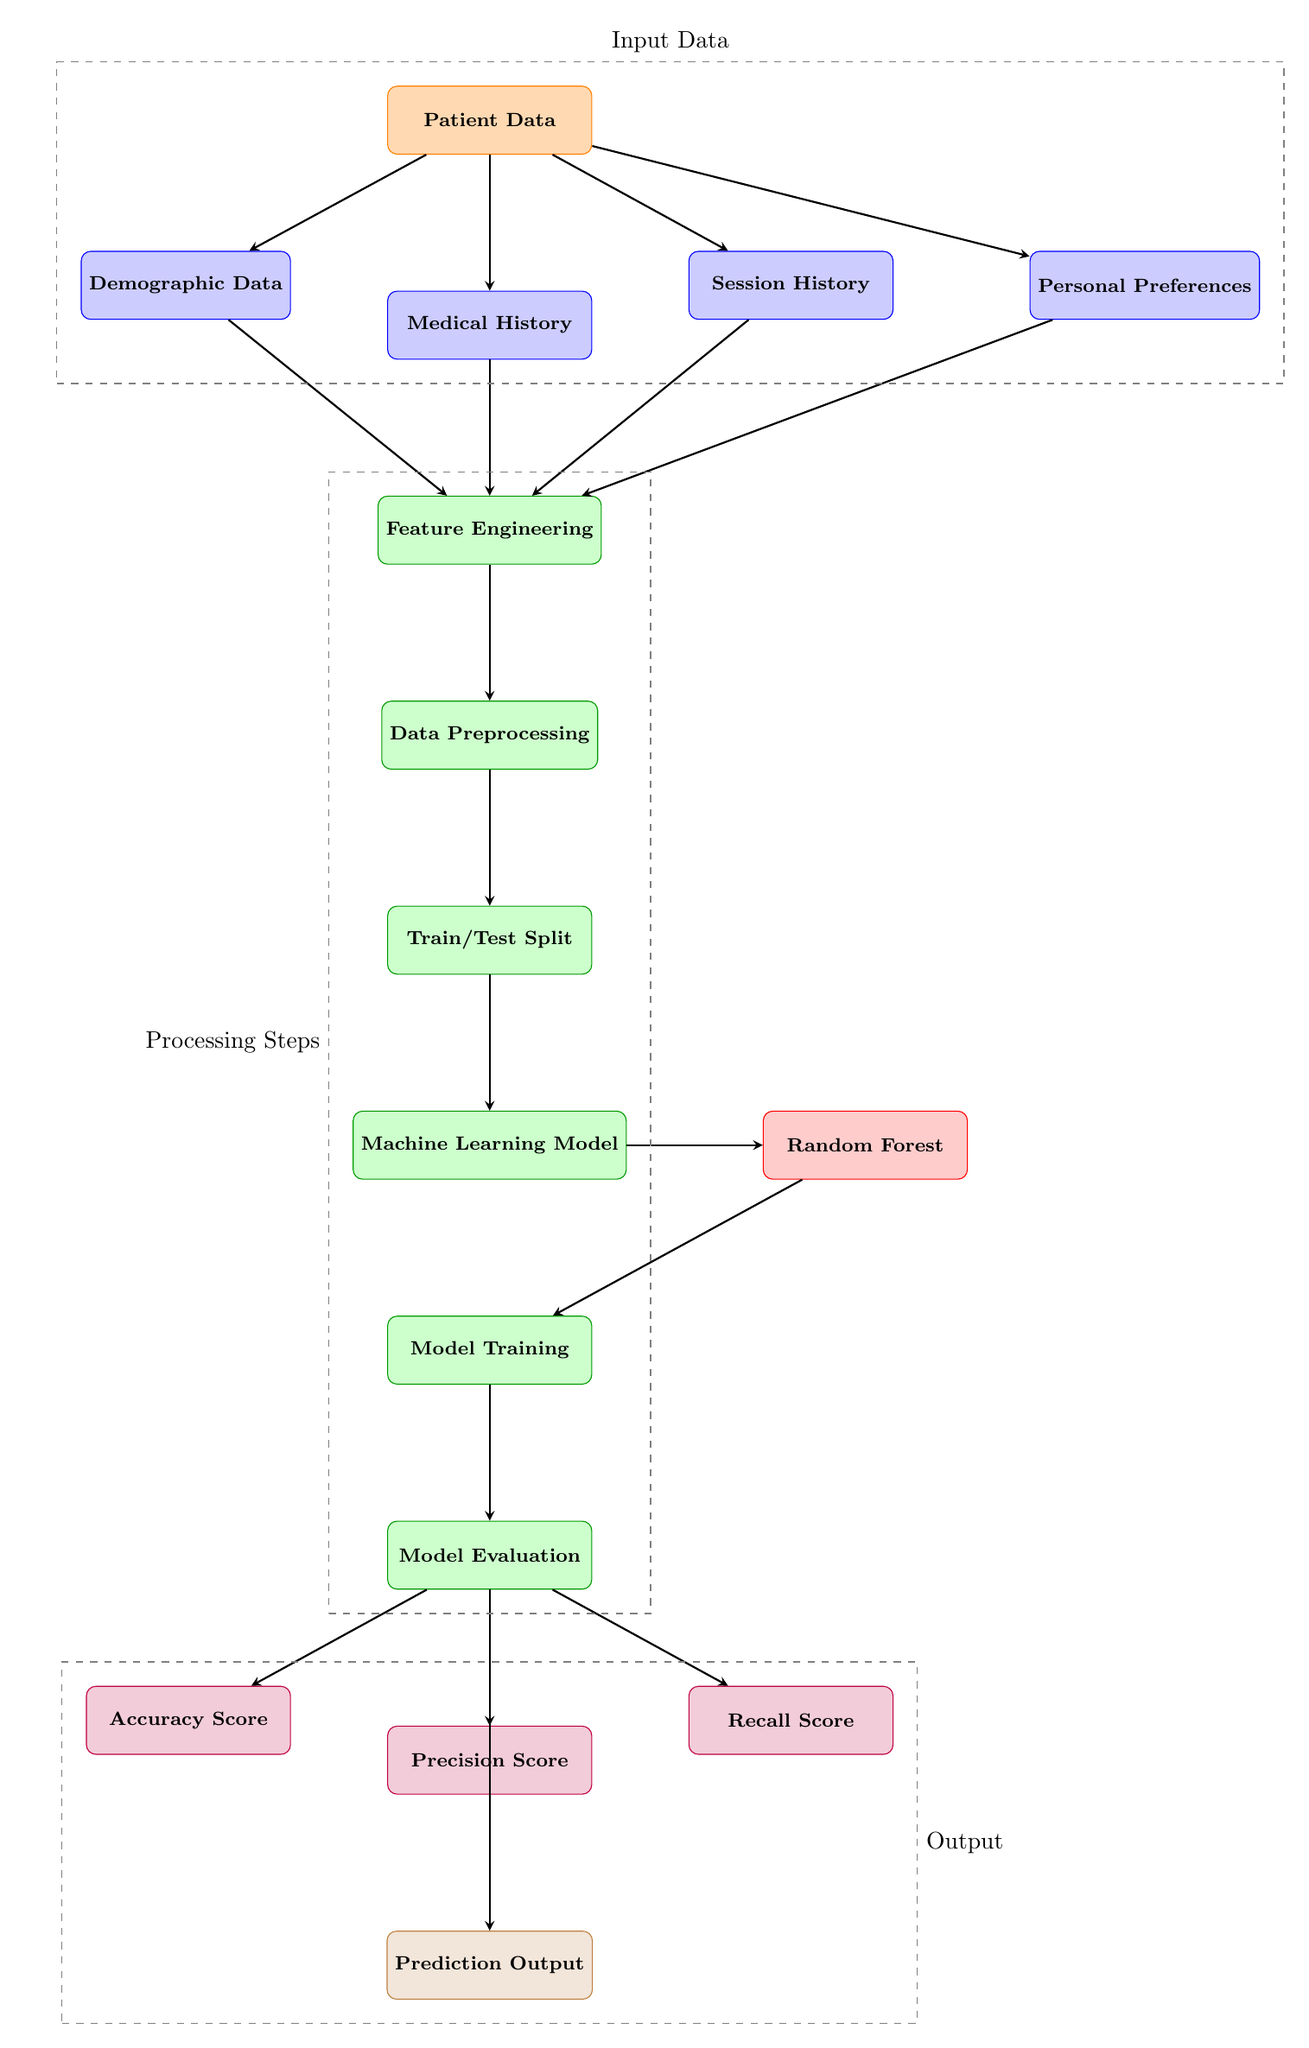What is the input to the model in this diagram? The input to the model consists of the Patient Data, which includes data from various sources like demographic data, medical history, session history, and personal preferences.
Answer: Patient Data How many metrics are evaluated in this diagram? The diagram shows three metrics being evaluated: Accuracy Score, Precision Score, and Recall Score.
Answer: Three What type of machine learning model is specified in the diagram? The diagram specifies a Random Forest model as the machine learning model used after the training process.
Answer: Random Forest What is the first processing step after feature engineering? The first processing step after feature engineering is Data Preprocessing, which prepares the data for model training.
Answer: Data Preprocessing Which data source directly connects to session history? The session history connects directly to Patient Data, which provides the necessary input data for the model.
Answer: Patient Data What does the model output predict? The model output is Prediction Output, indicating the expected attendance of therapy sessions based on the data provided.
Answer: Prediction Output What is the last step before generating the prediction output? The last step before generating the prediction output is Model Evaluation, which assesses the performance of the trained model using the test data.
Answer: Model Evaluation Which data type is used in feature engineering? Feature engineering utilizes Demographic Data, Medical History, Session History, and Personal Preferences to create features for the model.
Answer: All mentioned data types How many arrows point to the model training process? There is one arrow pointing to the Model Training process, which is the result of the Train/Test Split step.
Answer: One 